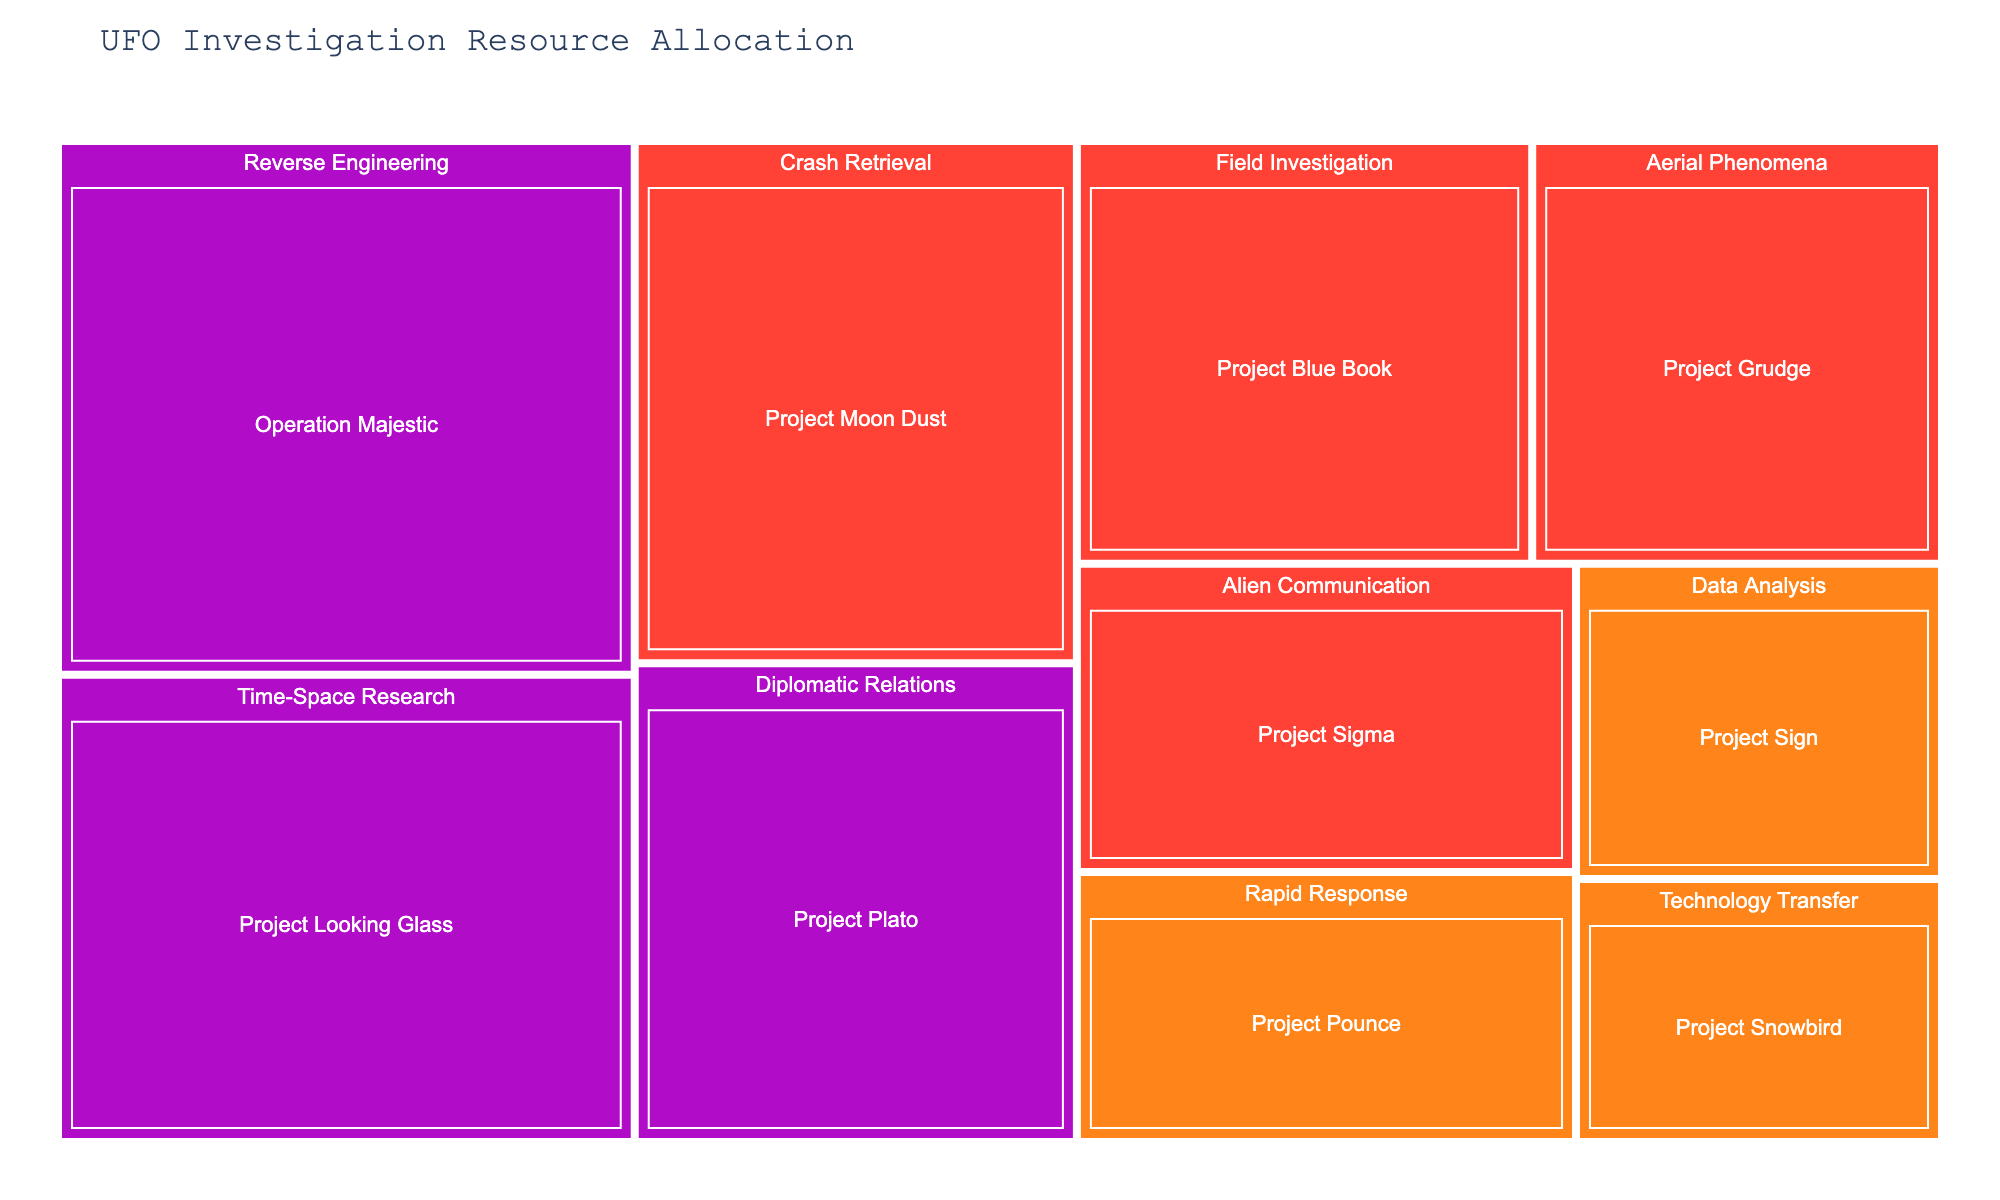How is the budget distributed among the different project types? The treemap shows different sized rectangles for each project type, where the size of each rectangle represents the budget allocated. For instance, "Reverse Engineering" has a larger rectangle, indicating a higher budget compared to other project types like "Technology Transfer".
Answer: Unevenly Can you identify which project has the highest budget? By observing the largest rectangle in the treemap, we can see that "Operation Majestic" receives the highest budget allocation.
Answer: Operation Majestic What is the total budget allocated to projects that require Top Secret clearance? Sum the budgets of "Project Blue Book", "Project Grudge", "Project Moon Dust", "Project Sigma" which all have Top Secret clearance: $5,000,000 + $4,500,000 + $6,000,000 + $4,000,000 = $19,500,000.
Answer: $19,500,000 Which project type encompasses the greatest number of individual projects? Count the number of individual projects within each project type. "Field Investigation", "Data Analysis", "Aerial Phenomena" each have one project, but "Cosmic Top Secret" projects are spread over three different types (Reverse Engineering, Time-Space Research, Diplomatic Relations) encompassing the most diverse allocations.
Answer: Cosmic Top Secret Compare the budget allocation between projects with Secret and Cosmic Top Secret clearances. Sum the budgets of projects with Secret clearance: "Project Sign", "Project Snowbird", and "Project Pounce", then sum the budgets of Cosmic Top Secret clearance: "Operation Majestic", "Project Looking Glass", and "Project Plato". Secret's total is $3,000,000 + $2,500,000 + $3,500,000 = $9,000,000. Cosmic Top Secret's total is $8,000,000 + $7,000,000 + $5,500,000 = $20,500,000.
Answer: Secret: $9,000,000, Cosmic Top Secret: $20,500,000 Which project type is associated with the highest security clearance level? Identify the project type with the largest budget section colored in 'Cosmic Top Secret' color, indicating the highest security clearance. The project type "Reverse Engineering" has the largest rectangle in that color.
Answer: Reverse Engineering How much more budget does the "Crash Retrieval" type receive compared to "Technology Transfer"? Compare the budgets of "Project Moon Dust" under "Crash Retrieval" and "Project Snowbird" under "Technology Transfer". $6,000,000 (Crash Retrieval) - $2,500,000 (Technology Transfer) = $3,500,000.
Answer: $3,500,000 Are there any projects that have more than $7,000,000 in budget? If so, which ones? Observe the treemap and identify projects with budgets greater than $7,000,000. Both "Operation Majestic" and "Project Looking Glass" have budgets over $7,000,000.
Answer: Operation Majestic, Project Looking Glass What's the average budget for projects with Cosmic Top Secret clearance? Calculate the average of the budgets for "Operation Majestic", "Project Looking Glass", and "Project Plato". ($8,000,000 + $7,000,000 + $5,500,000) / 3 = $20,500,000 / 3 ≈ $6,833,333
Answer: $6,833,333 How are the projects grouped based on their security clearance level? The treemap uses different colors to represent different security clearance levels. Projects like "Project Blue Book", "Project Grudge", "Project Moon Dust", and "Project Sigma" are grouped under Top Secret, while "Project Sign", "Project Snowbird", and "Project Pounce" are under Secret. "Operation Majestic", "Project Looking Glass", and "Project Plato" are under Cosmic Top Secret.
Answer: Grouped by colors: Top Secret in red, Secret in orange, and Cosmic Top Secret in purple 